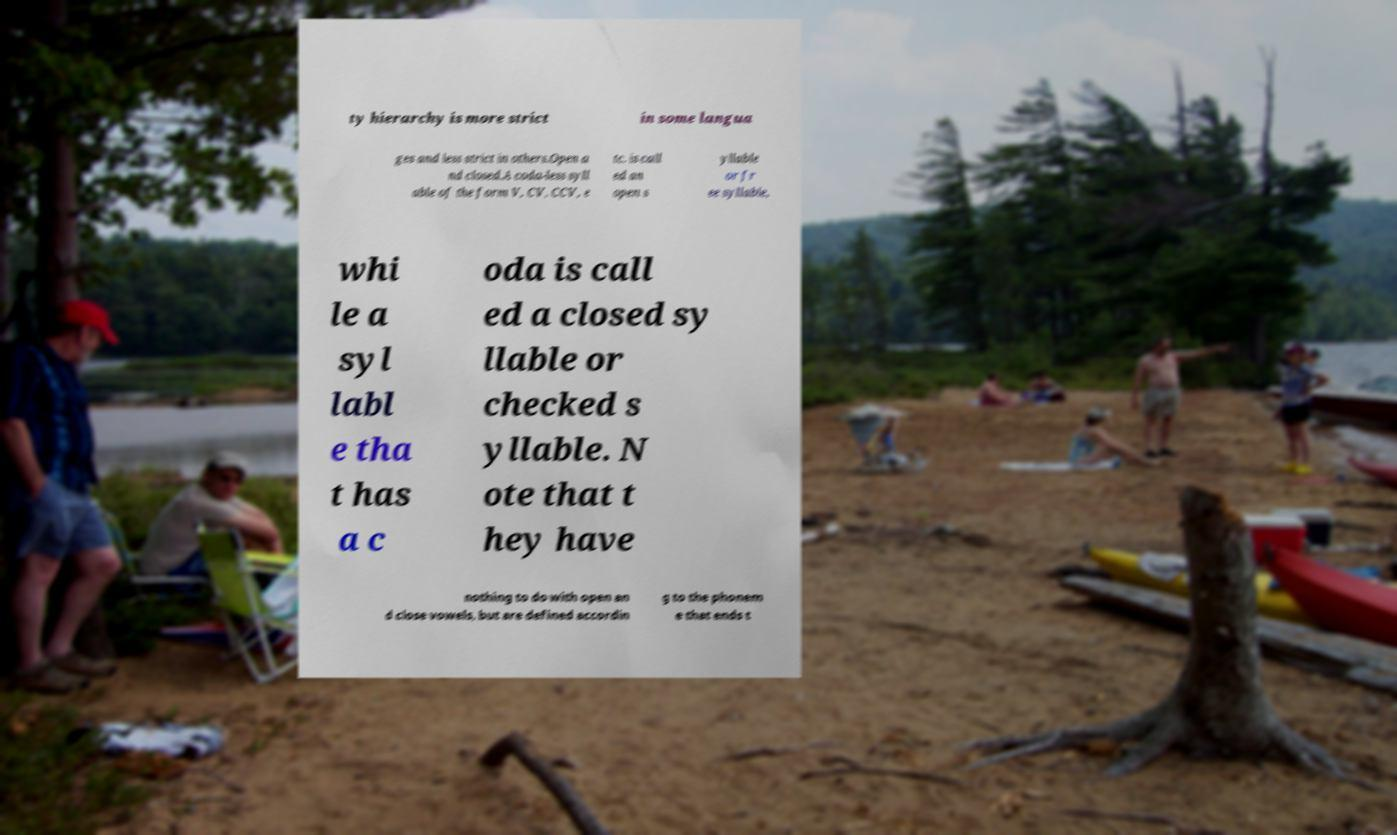What messages or text are displayed in this image? I need them in a readable, typed format. ty hierarchy is more strict in some langua ges and less strict in others.Open a nd closed.A coda-less syll able of the form V, CV, CCV, e tc. is call ed an open s yllable or fr ee syllable, whi le a syl labl e tha t has a c oda is call ed a closed sy llable or checked s yllable. N ote that t hey have nothing to do with open an d close vowels, but are defined accordin g to the phonem e that ends t 